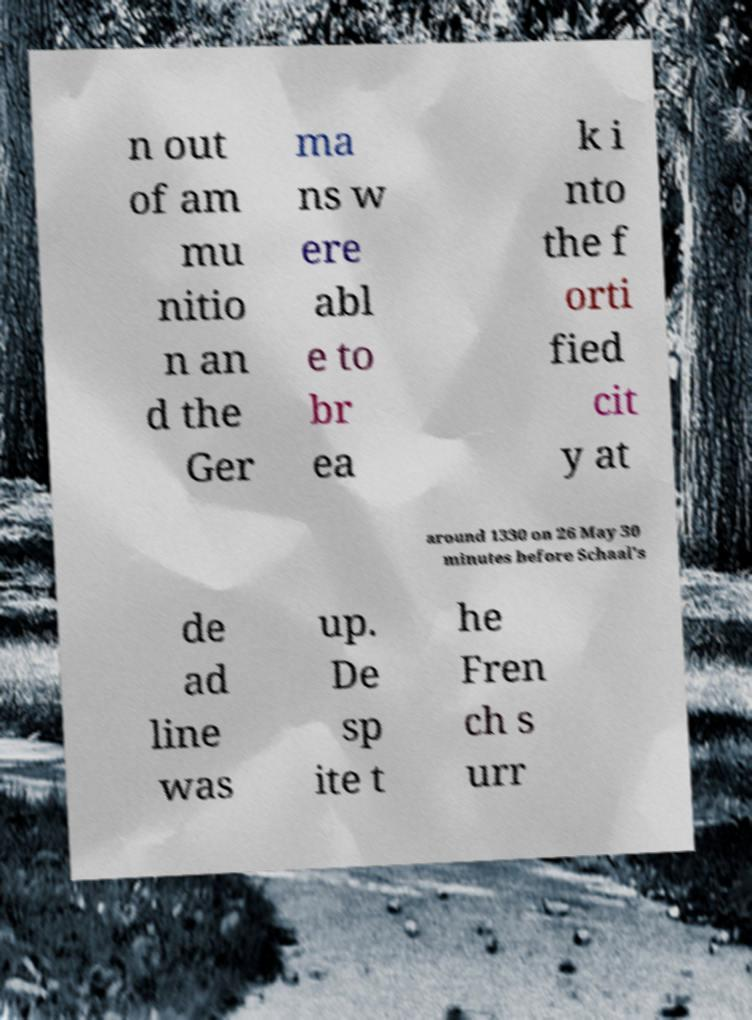There's text embedded in this image that I need extracted. Can you transcribe it verbatim? n out of am mu nitio n an d the Ger ma ns w ere abl e to br ea k i nto the f orti fied cit y at around 1330 on 26 May 30 minutes before Schaal's de ad line was up. De sp ite t he Fren ch s urr 